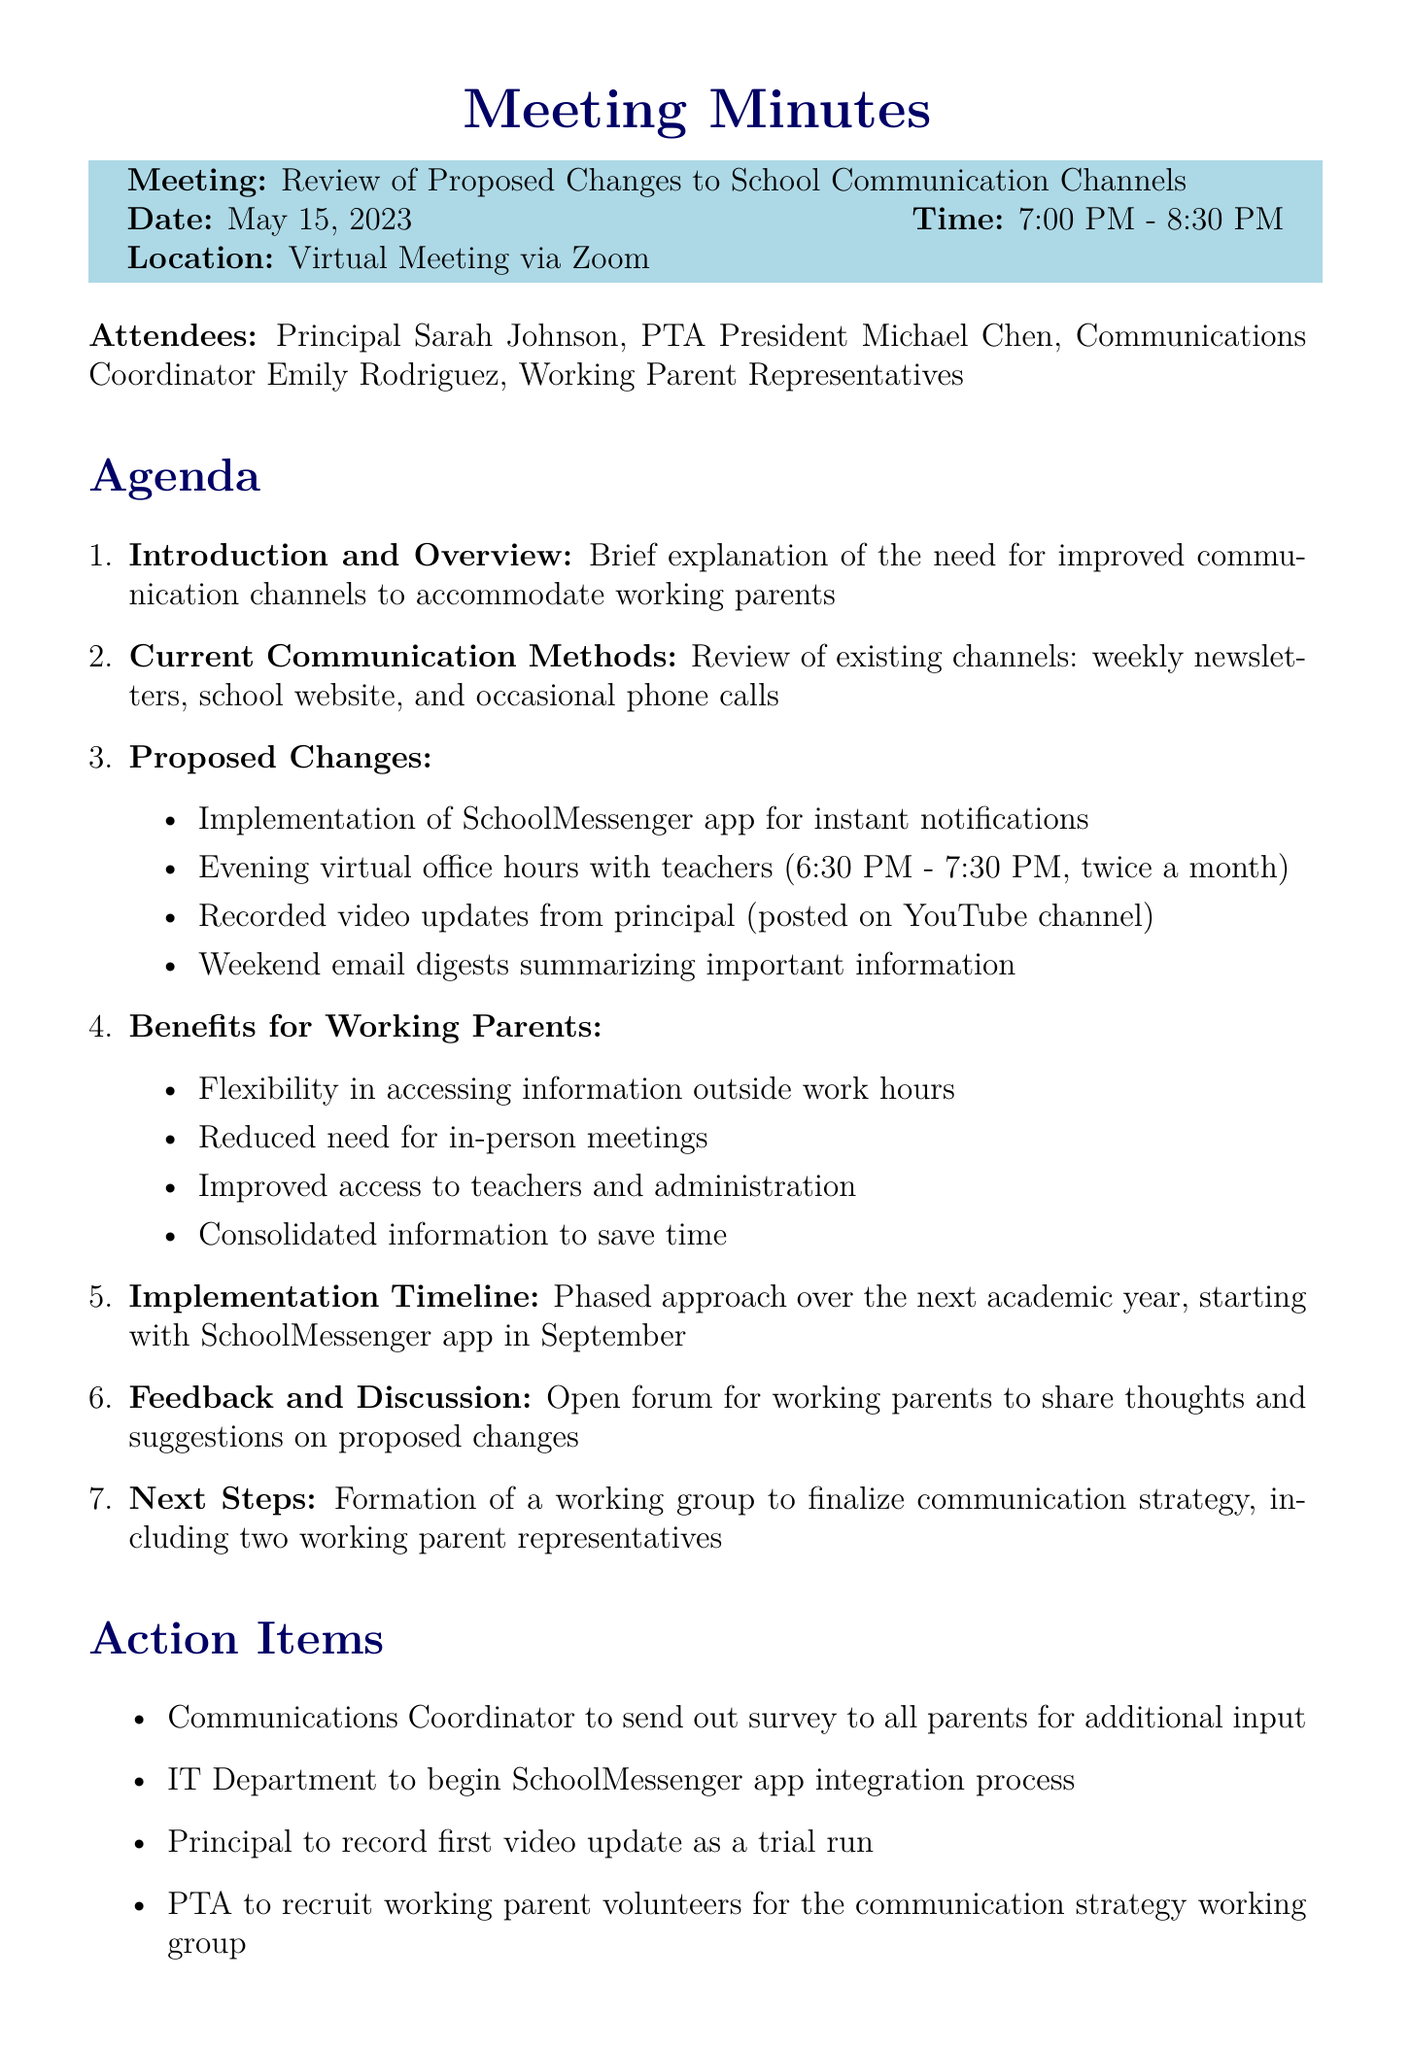What is the meeting date? The meeting date is specifically stated in the document as May 15, 2023.
Answer: May 15, 2023 Who is the PTA President? The document lists the PTA President as Michael Chen during the meeting.
Answer: Michael Chen What is one proposed change to school communication channels? The document includes several proposed changes, one of which is the implementation of the SchoolMessenger app for instant notifications.
Answer: SchoolMessenger app When are the evening virtual office hours scheduled? The document specifies that the evening virtual office hours with teachers are twice a month from 6:30 PM to 7:30 PM.
Answer: 6:30 PM - 7:30 PM, twice a month What is a benefit listed for working parents? The document mentions several benefits, including flexibility in accessing information outside work hours.
Answer: Flexibility in accessing information outside work hours How will feedback be collected from parents? According to the action items in the document, a survey will be sent out to all parents for additional input.
Answer: Survey What is the implementation start month for the SchoolMessenger app? The document states that the phased approach is to start with the SchoolMessenger app in September.
Answer: September How many working parent representatives will be included in the working group? The document clearly mentions that two working parent representatives will be part of the formation of the working group.
Answer: Two 